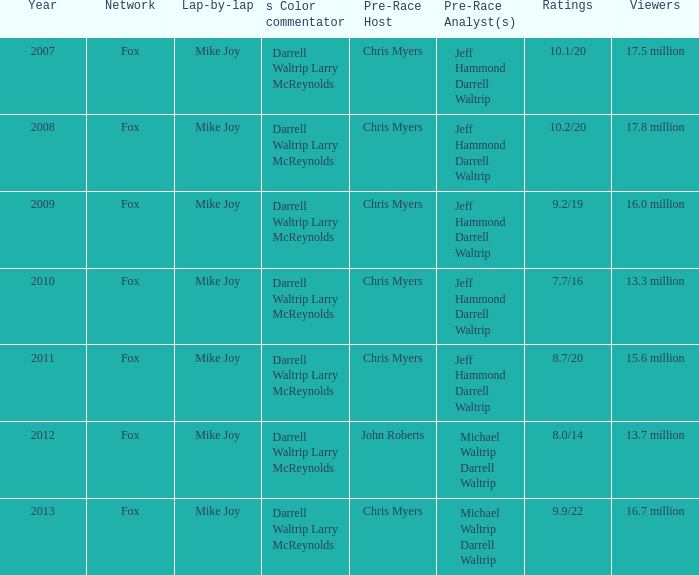Which year has the lowest number of viewers at 1 2012.0. 